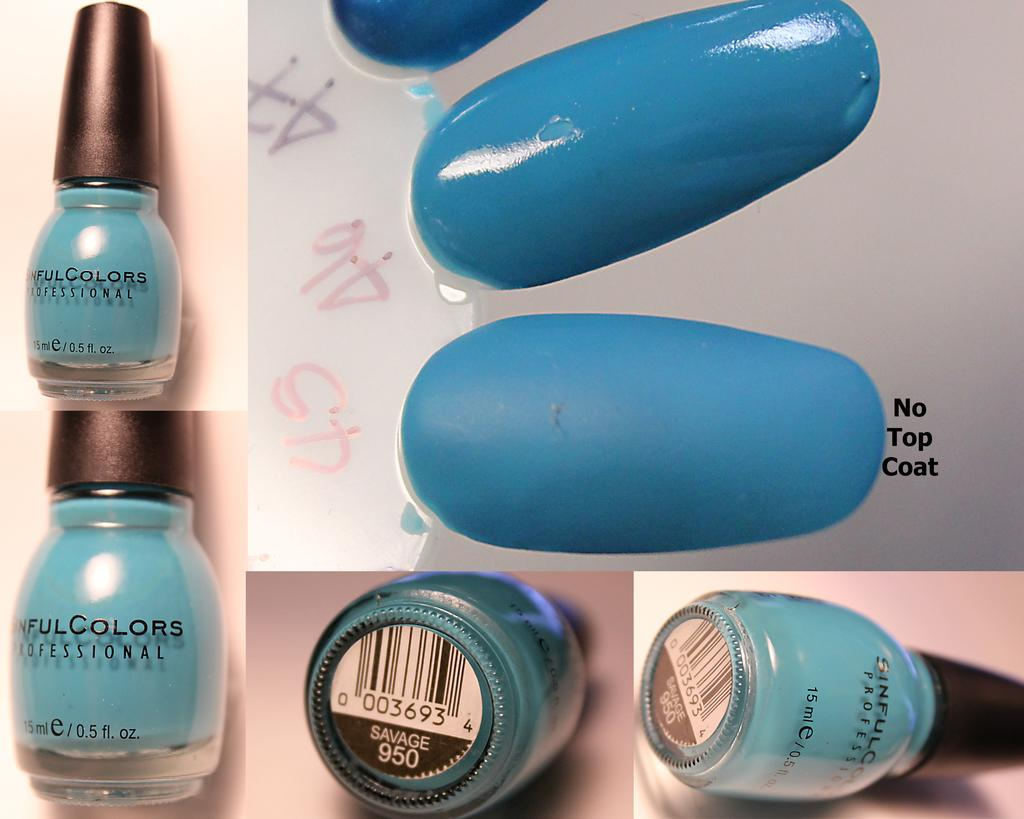<image>
Relay a brief, clear account of the picture shown. Blue nail polish called Savage shown with and without top coat. 